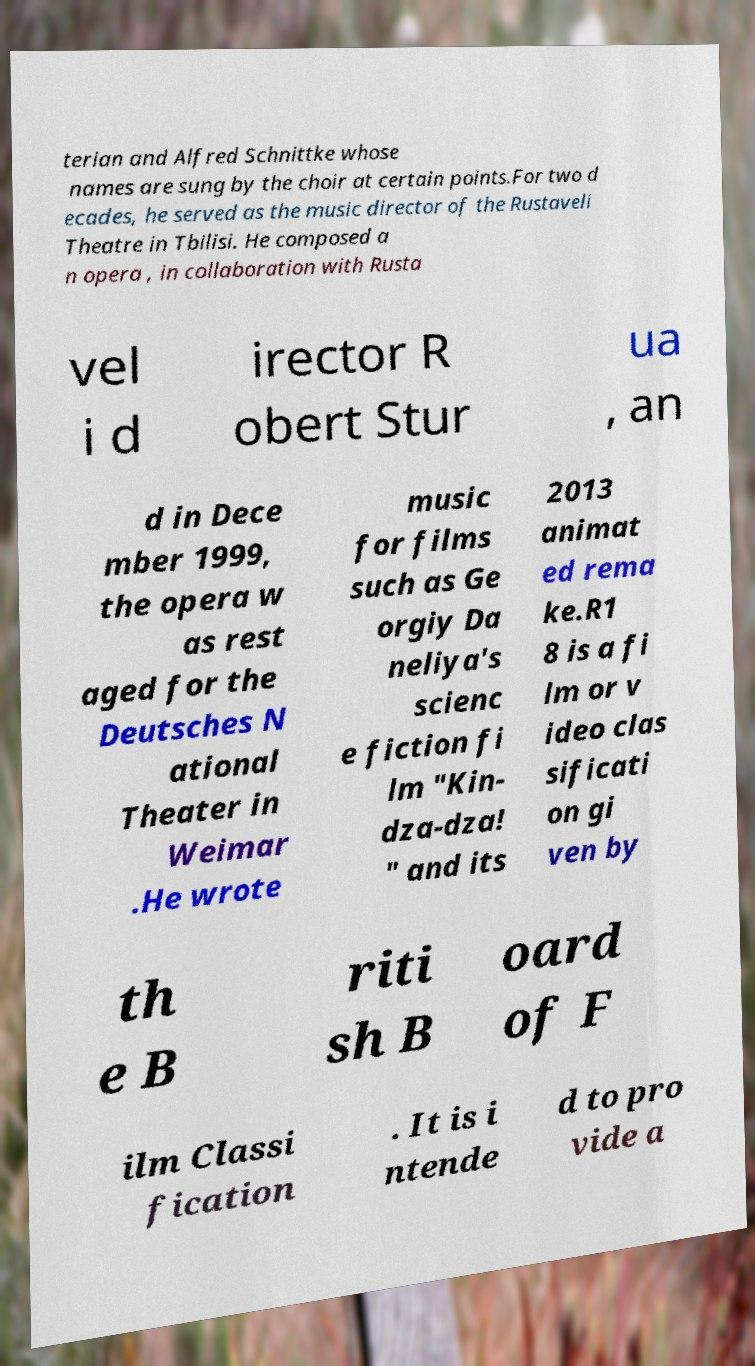For documentation purposes, I need the text within this image transcribed. Could you provide that? terian and Alfred Schnittke whose names are sung by the choir at certain points.For two d ecades, he served as the music director of the Rustaveli Theatre in Tbilisi. He composed a n opera , in collaboration with Rusta vel i d irector R obert Stur ua , an d in Dece mber 1999, the opera w as rest aged for the Deutsches N ational Theater in Weimar .He wrote music for films such as Ge orgiy Da neliya's scienc e fiction fi lm "Kin- dza-dza! " and its 2013 animat ed rema ke.R1 8 is a fi lm or v ideo clas sificati on gi ven by th e B riti sh B oard of F ilm Classi fication . It is i ntende d to pro vide a 